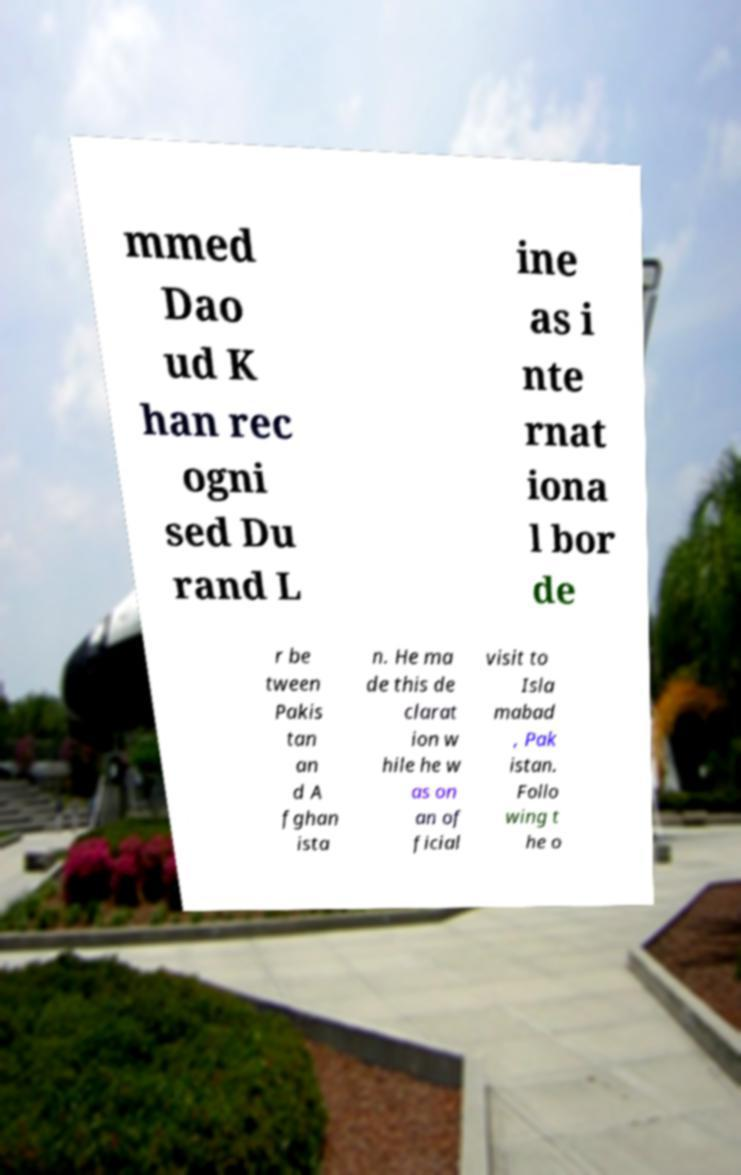Please identify and transcribe the text found in this image. mmed Dao ud K han rec ogni sed Du rand L ine as i nte rnat iona l bor de r be tween Pakis tan an d A fghan ista n. He ma de this de clarat ion w hile he w as on an of ficial visit to Isla mabad , Pak istan. Follo wing t he o 